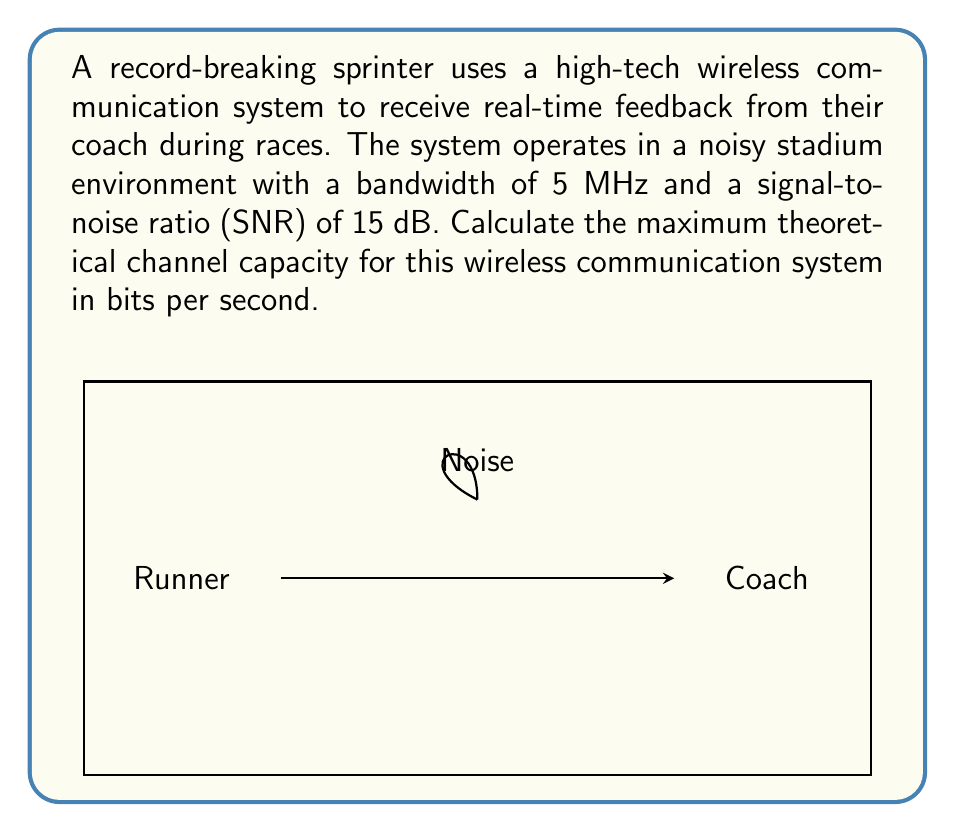Can you answer this question? To solve this problem, we'll use the Shannon-Hartley theorem, which gives the channel capacity for a communication channel with Gaussian noise.

Step 1: Recall the Shannon-Hartley theorem
The channel capacity $C$ in bits per second is given by:

$$C = B \log_2(1 + SNR)$$

Where:
$B$ is the bandwidth in Hz
$SNR$ is the signal-to-noise ratio (linear, not dB)

Step 2: Convert the given SNR from dB to linear scale
$SNR_{dB} = 15$ dB
$SNR_{linear} = 10^{SNR_{dB}/10} = 10^{15/10} \approx 31.6228$

Step 3: Apply the Shannon-Hartley theorem
$B = 5$ MHz $= 5 \times 10^6$ Hz
$SNR_{linear} \approx 31.6228$

$$\begin{align}
C &= (5 \times 10^6) \log_2(1 + 31.6228) \\
&\approx (5 \times 10^6) \log_2(32.6228) \\
&\approx (5 \times 10^6) \times 5.0279 \\
&\approx 25.1395 \times 10^6 \text{ bits/second}
\end{align}$$

Step 4: Round to a reasonable number of significant figures
$C \approx 25.14 \times 10^6$ bits/second or 25.14 Mbps
Answer: 25.14 Mbps 